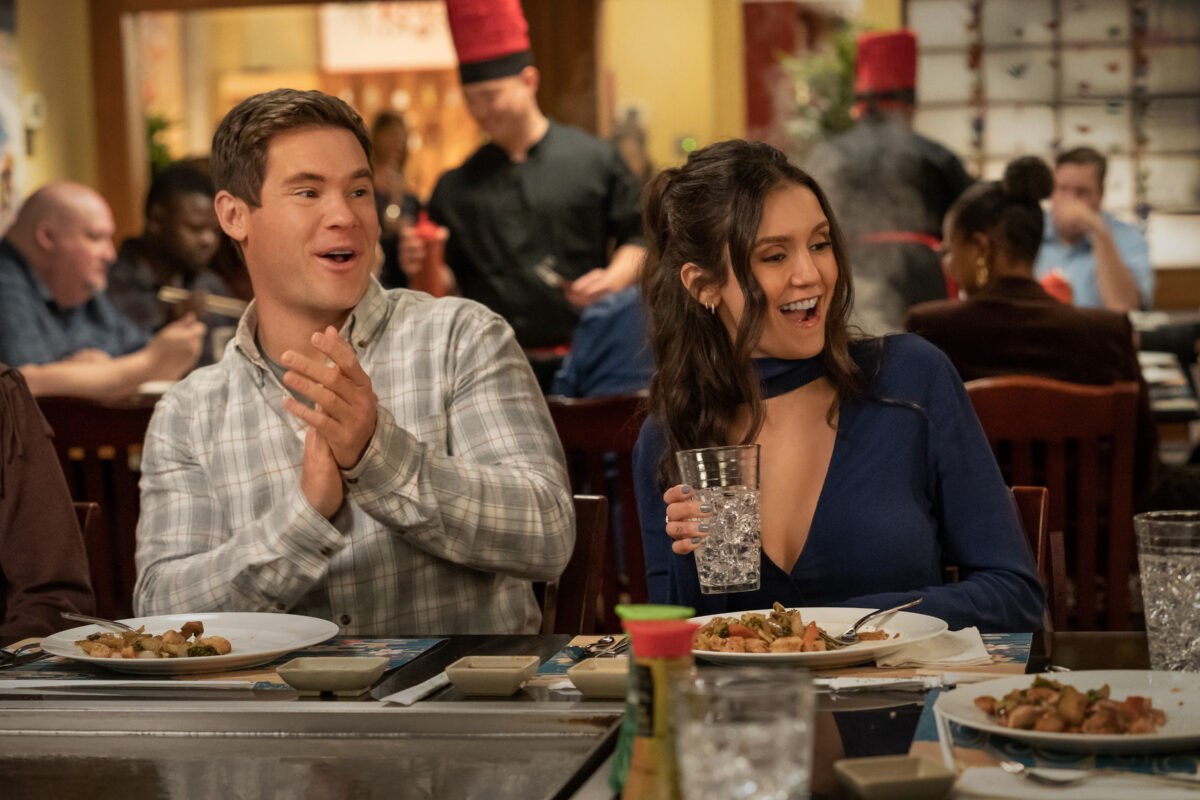Can you elaborate on the elements of the picture provided? The image captures two people at a lively restaurant, engaged in an enjoyable moment. The man, dressed casually in a patterned shirt, is clapping and looking at the woman with a smile. The woman, in a striking blue top with a unique neckline, is laughing, her attention fully on the man. They are seated at a teppanyaki table with various dishes in front of them, suggesting a festive or celebratory dinner. The background shows other diners and a chef at the grill, contributing to the bustling atmosphere. 